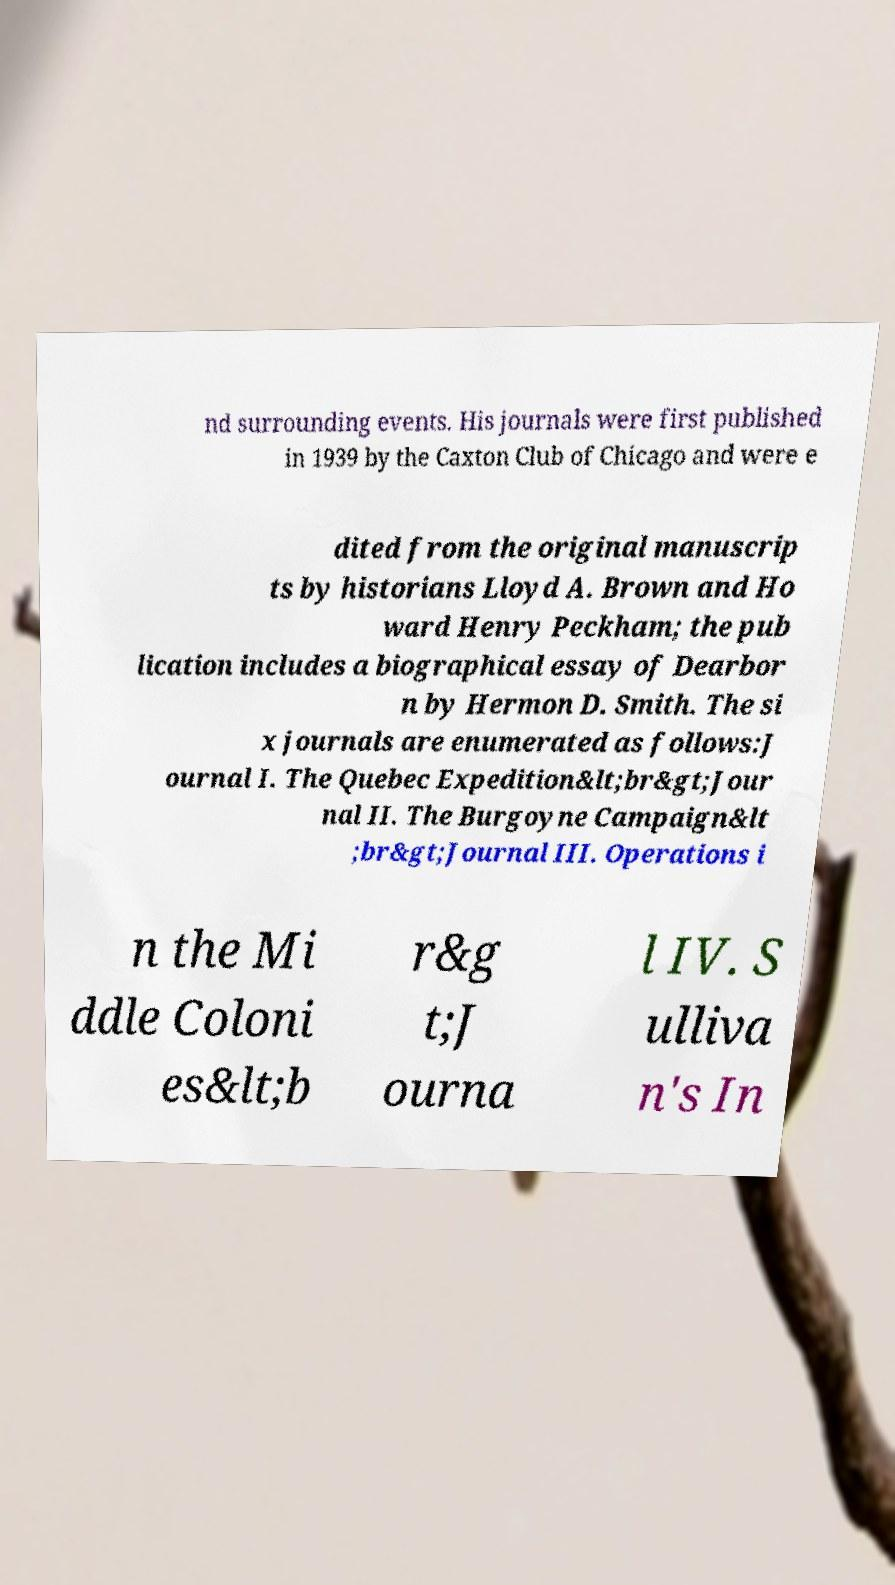Can you read and provide the text displayed in the image?This photo seems to have some interesting text. Can you extract and type it out for me? nd surrounding events. His journals were first published in 1939 by the Caxton Club of Chicago and were e dited from the original manuscrip ts by historians Lloyd A. Brown and Ho ward Henry Peckham; the pub lication includes a biographical essay of Dearbor n by Hermon D. Smith. The si x journals are enumerated as follows:J ournal I. The Quebec Expedition&lt;br&gt;Jour nal II. The Burgoyne Campaign&lt ;br&gt;Journal III. Operations i n the Mi ddle Coloni es&lt;b r&g t;J ourna l IV. S ulliva n's In 